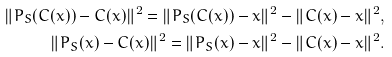Convert formula to latex. <formula><loc_0><loc_0><loc_500><loc_500>\| P _ { S } ( C ( x ) ) - C ( x ) \| ^ { 2 } = \| P _ { S } ( C ( x ) ) - x \| ^ { 2 } - \| C ( x ) - x \| ^ { 2 } , \\ \| P _ { S } ( x ) - C ( x ) \| ^ { 2 } = \| P _ { S } ( x ) - x \| ^ { 2 } - \| C ( x ) - x \| ^ { 2 } .</formula> 